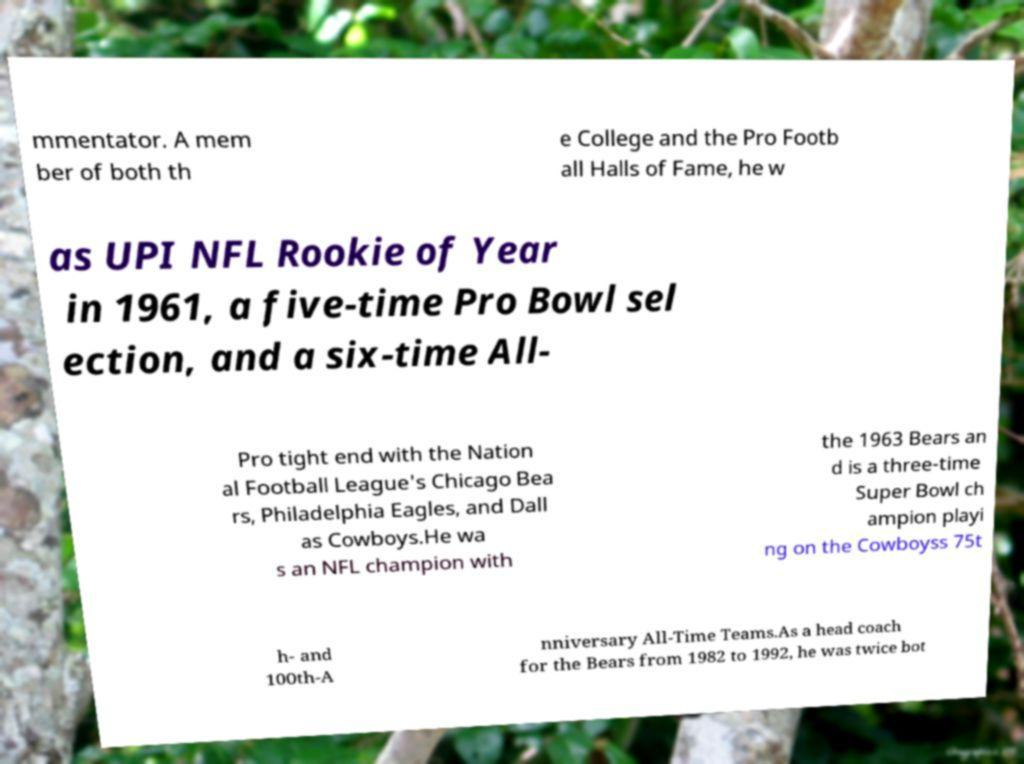Please identify and transcribe the text found in this image. mmentator. A mem ber of both th e College and the Pro Footb all Halls of Fame, he w as UPI NFL Rookie of Year in 1961, a five-time Pro Bowl sel ection, and a six-time All- Pro tight end with the Nation al Football League's Chicago Bea rs, Philadelphia Eagles, and Dall as Cowboys.He wa s an NFL champion with the 1963 Bears an d is a three-time Super Bowl ch ampion playi ng on the Cowboyss 75t h- and 100th-A nniversary All-Time Teams.As a head coach for the Bears from 1982 to 1992, he was twice bot 